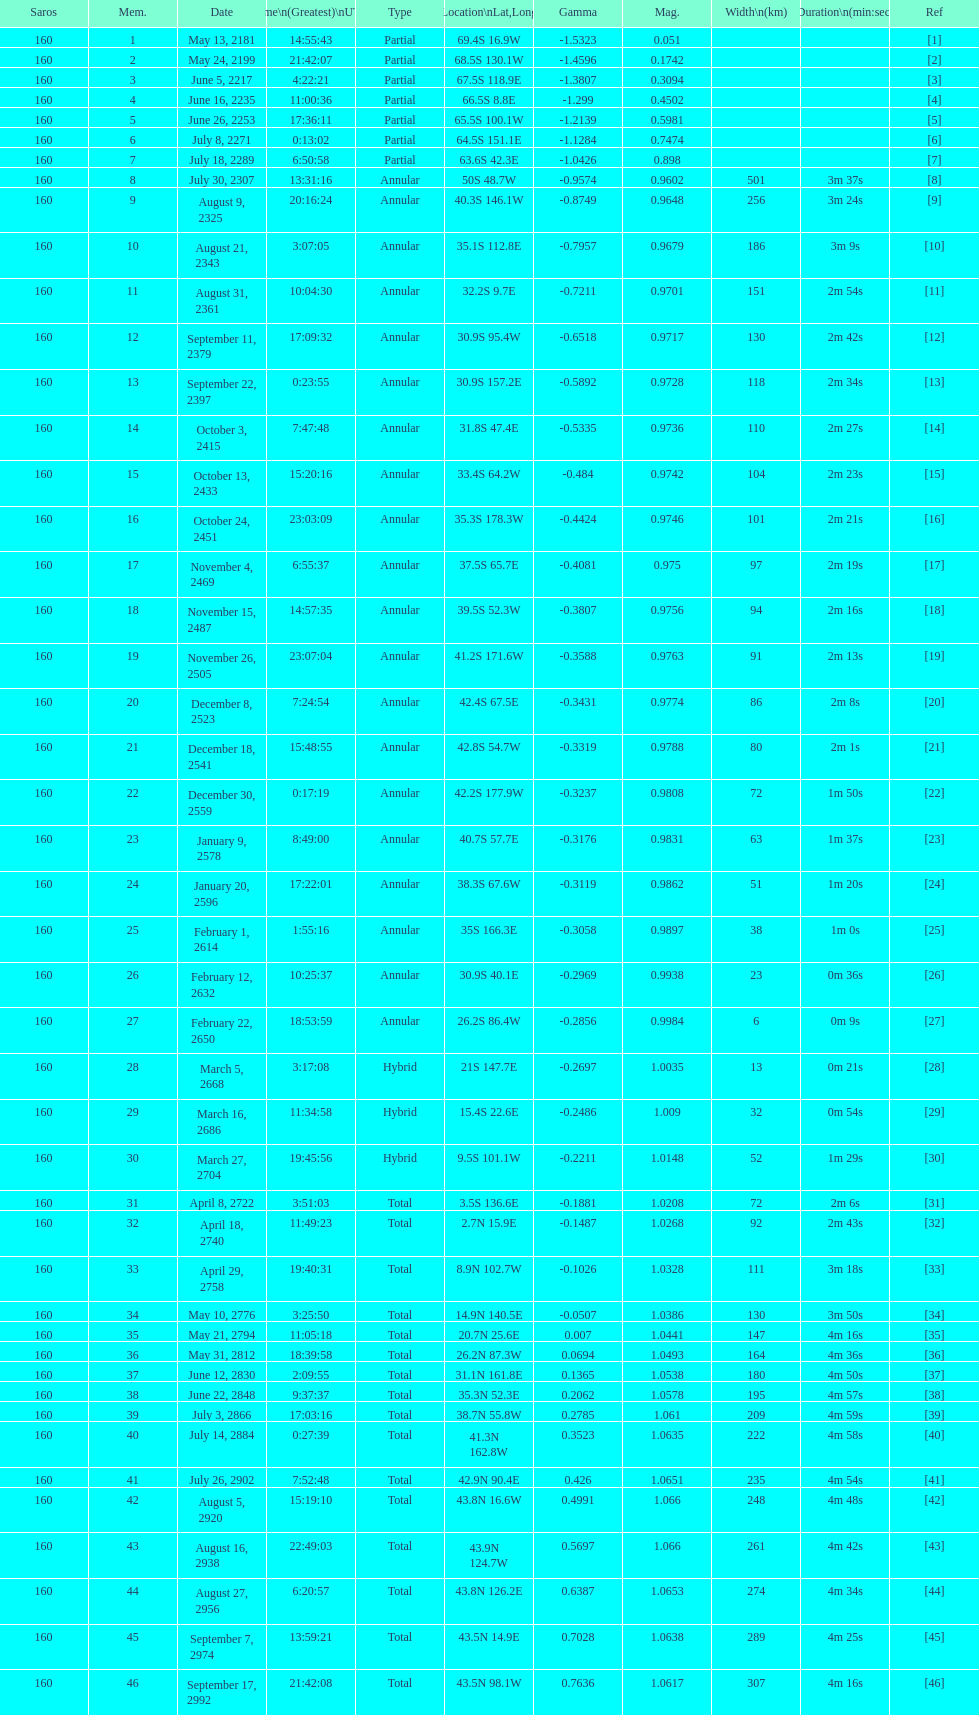Which one has a larger width, 8 or 21? 8. 